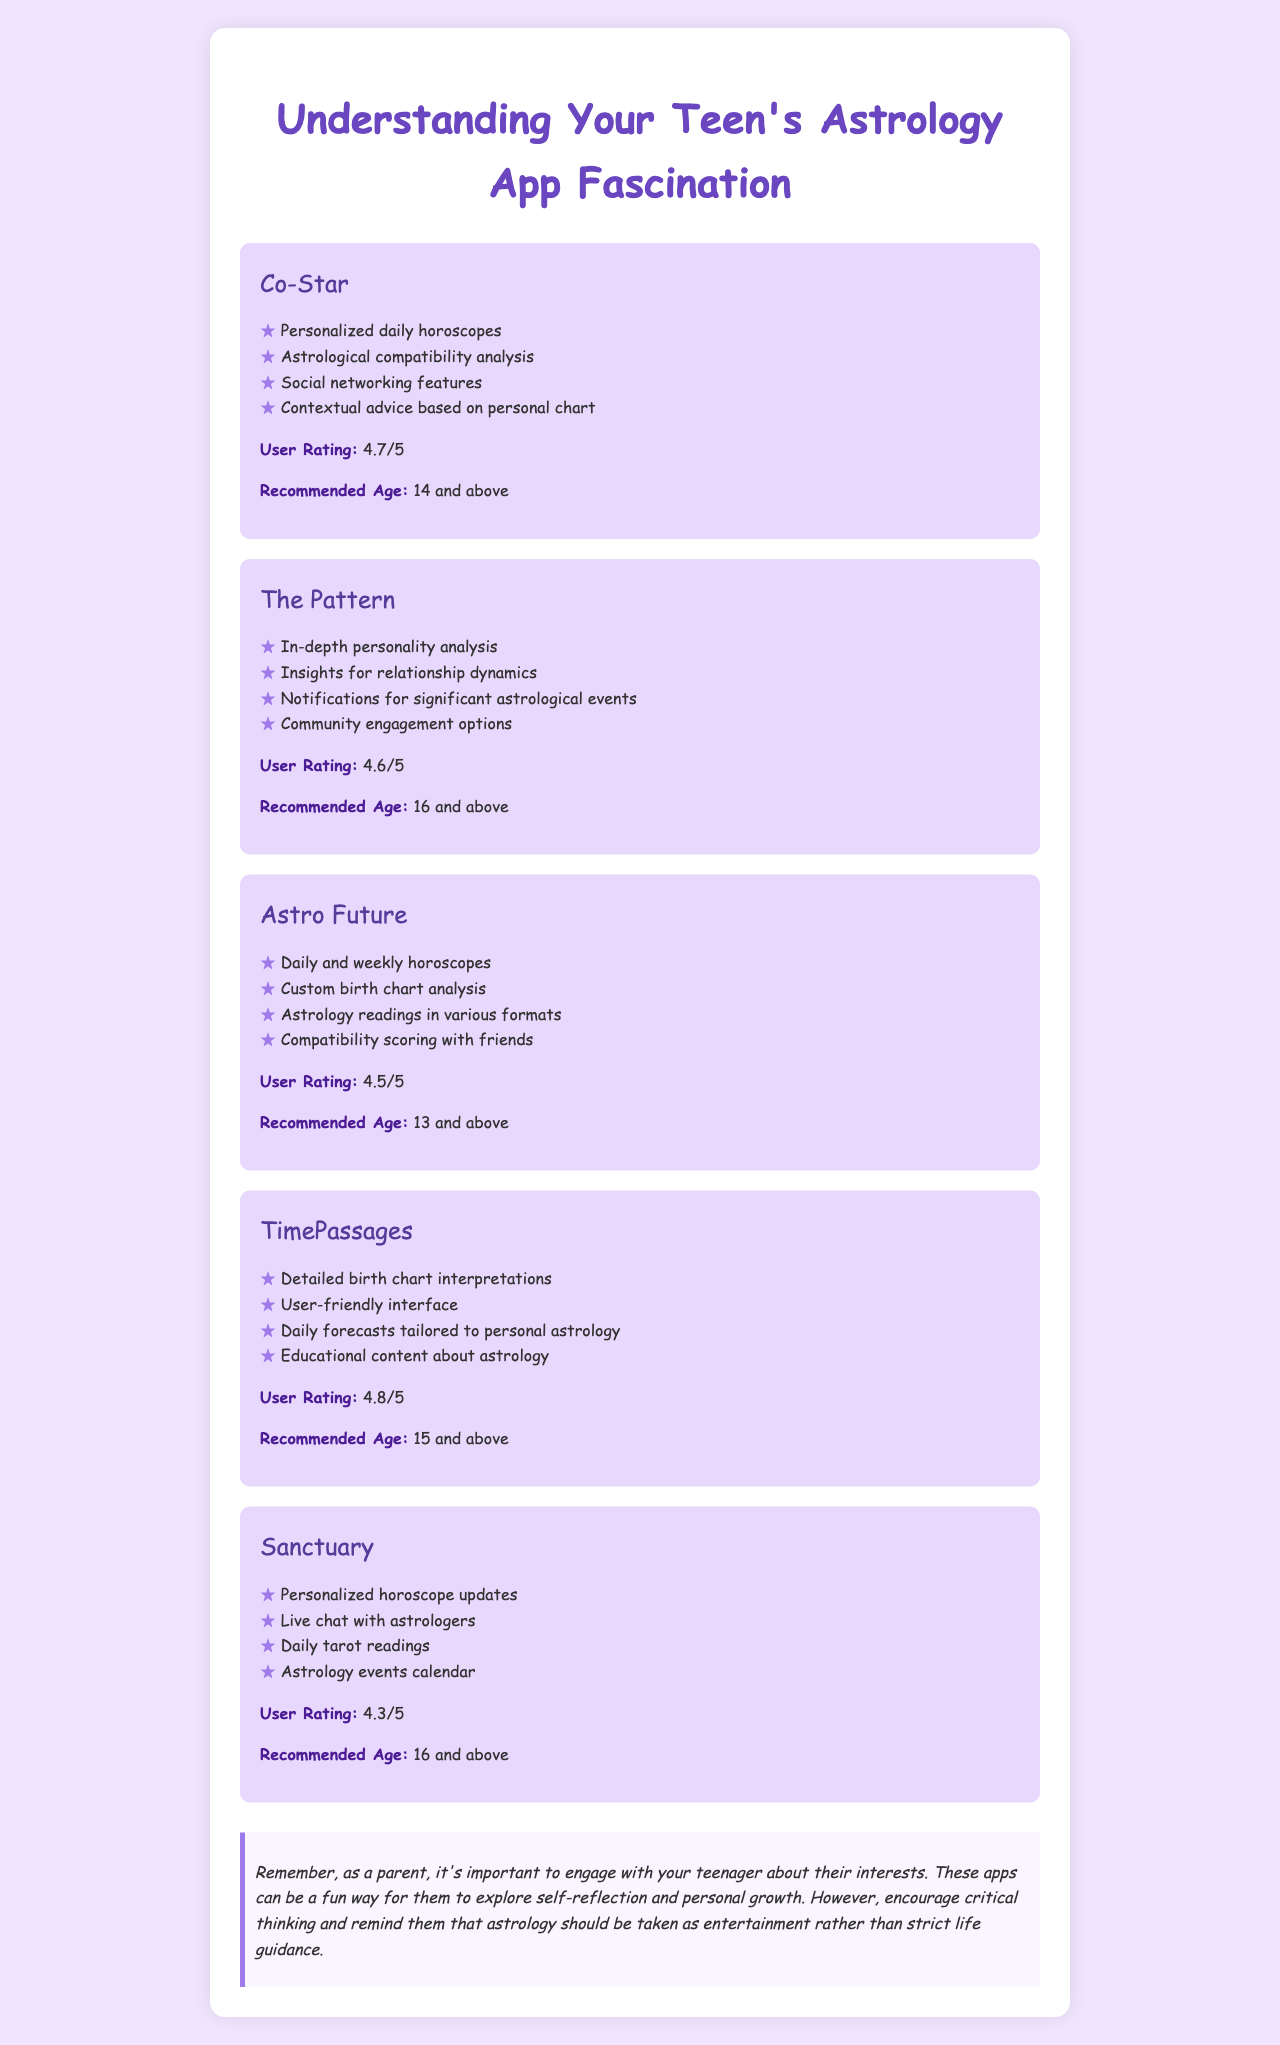what is the user rating of Co-Star? The user rating of Co-Star is mentioned in the document as 4.7/5.
Answer: 4.7/5 what are the features of The Pattern? The document lists features for The Pattern, which include in-depth personality analysis and relationship dynamics insights, among others.
Answer: In-depth personality analysis, insights for relationship dynamics, notifications for significant astrological events, community engagement options what is the recommended age for Astro Future? The recommended age for Astro Future is stated in the document as 13 and above.
Answer: 13 and above which astrology app has the highest user rating? The document notes that TimePassages has the highest user rating at 4.8/5.
Answer: TimePassages how many apps recommend an age of 16 and above? By analyzing the document, Sanctuary and The Pattern both recommend an age of 16 and above.
Answer: 2 apps what feature is common among all listed astrology apps? The document indicates that personalized horoscope updates or similar feature formats are available in all apps, highlighting personalization.
Answer: Personalized horoscope updates what is the purpose of the parent note in the document? The parent note emphasizes the importance of engaging with teenagers about their interests in astrology apps while encouraging critical thinking.
Answer: Engage with teenagers about their interests 